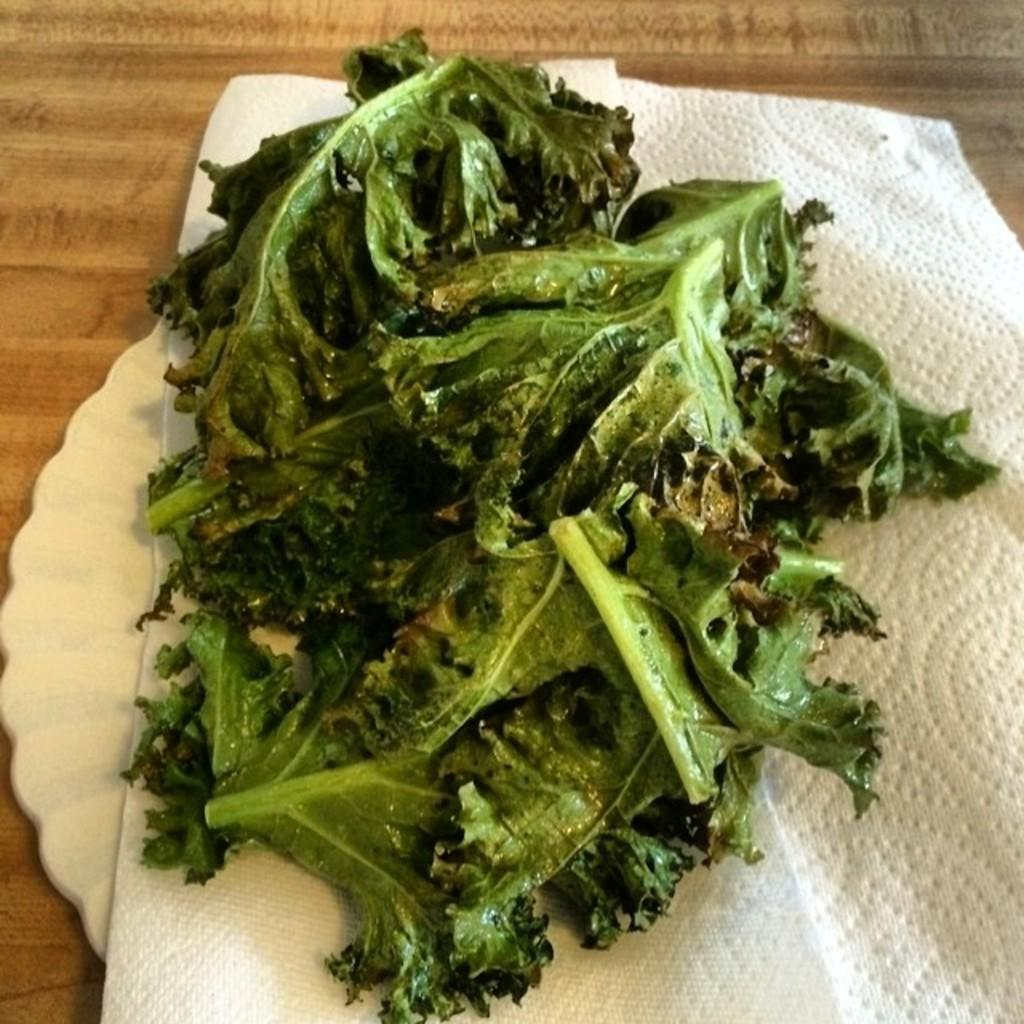Where was the image taken? The image is taken indoors. What furniture is present in the image? There is a table in the image. What is placed on the table? There is a plate on the table. What type of food is on the plate? There are leafy vegetables on the plate. What additional item is on the table? There is a tissue on the table. Can you see any cobwebs in the image? There is no mention of cobwebs in the image, so it cannot be determined if any are present. 